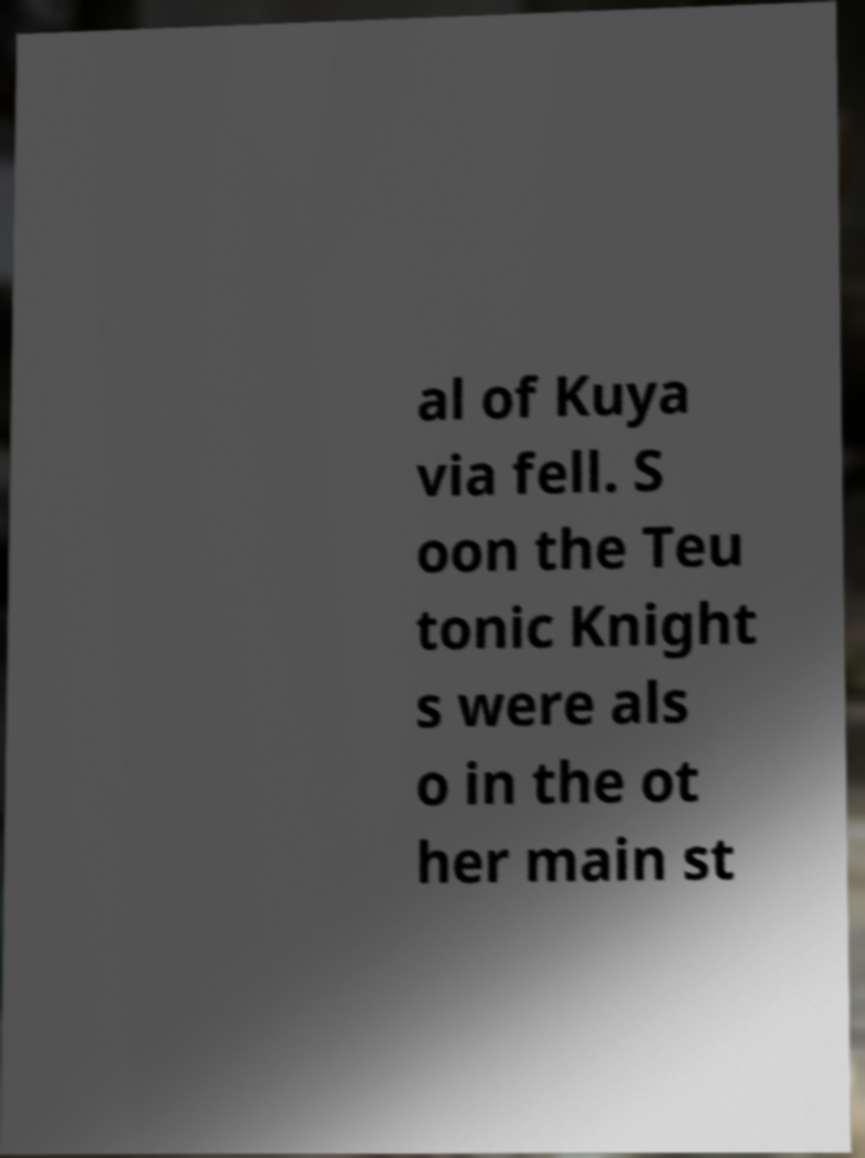Please read and relay the text visible in this image. What does it say? al of Kuya via fell. S oon the Teu tonic Knight s were als o in the ot her main st 